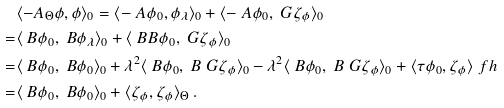<formula> <loc_0><loc_0><loc_500><loc_500>& \langle - A _ { \Theta } \phi , \phi \rangle _ { 0 } = \langle - \ A \phi _ { 0 } , \phi _ { \lambda } \rangle _ { 0 } + \langle - \ A \phi _ { 0 } , \ G \zeta _ { \phi } \rangle _ { 0 } \\ = & \langle \ B \phi _ { 0 } , \ B \phi _ { \lambda } \rangle _ { 0 } + \langle \ B B \phi _ { 0 } , \ G \zeta _ { \phi } \rangle _ { 0 } \\ = & \langle \ B \phi _ { 0 } , \ B \phi _ { 0 } \rangle _ { 0 } + \lambda ^ { 2 } \langle \ B \phi _ { 0 } , \ B \ G \zeta _ { \phi } \rangle _ { 0 } - \lambda ^ { 2 } \langle \ B \phi _ { 0 } , \ B \ G \zeta _ { \phi } \rangle _ { 0 } + \langle \tau \phi _ { 0 } , \zeta _ { \phi } \rangle _ { \ } f h \\ = & \langle \ B \phi _ { 0 } , \ B \phi _ { 0 } \rangle _ { 0 } + \langle \zeta _ { \phi } , \zeta _ { \phi } \rangle _ { \Theta } \, .</formula> 